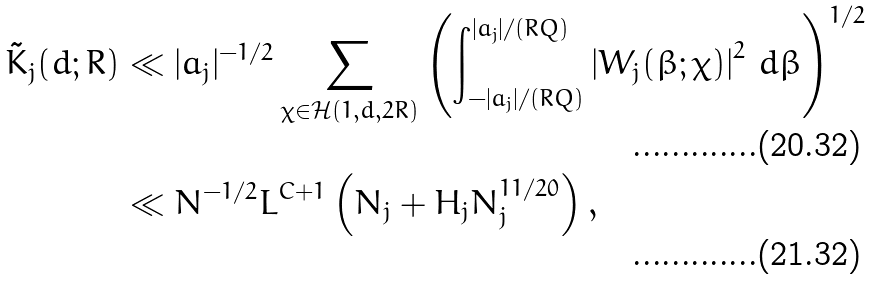Convert formula to latex. <formula><loc_0><loc_0><loc_500><loc_500>\tilde { K } _ { j } ( d ; R ) & \ll | a _ { j } | ^ { - 1 / 2 } \sum _ { \chi \in \mathcal { H } ( 1 , d , 2 R ) } \left ( \int _ { - | a _ { j } | / ( R Q ) } ^ { | a _ { j } | / ( R Q ) } \left | W _ { j } ( \beta ; \chi ) \right | ^ { 2 } \, d \beta \right ) ^ { 1 / 2 } \\ & \ll N ^ { - 1 / 2 } L ^ { C + 1 } \left ( N _ { j } + H _ { j } N _ { j } ^ { 1 1 / 2 0 } \right ) ,</formula> 